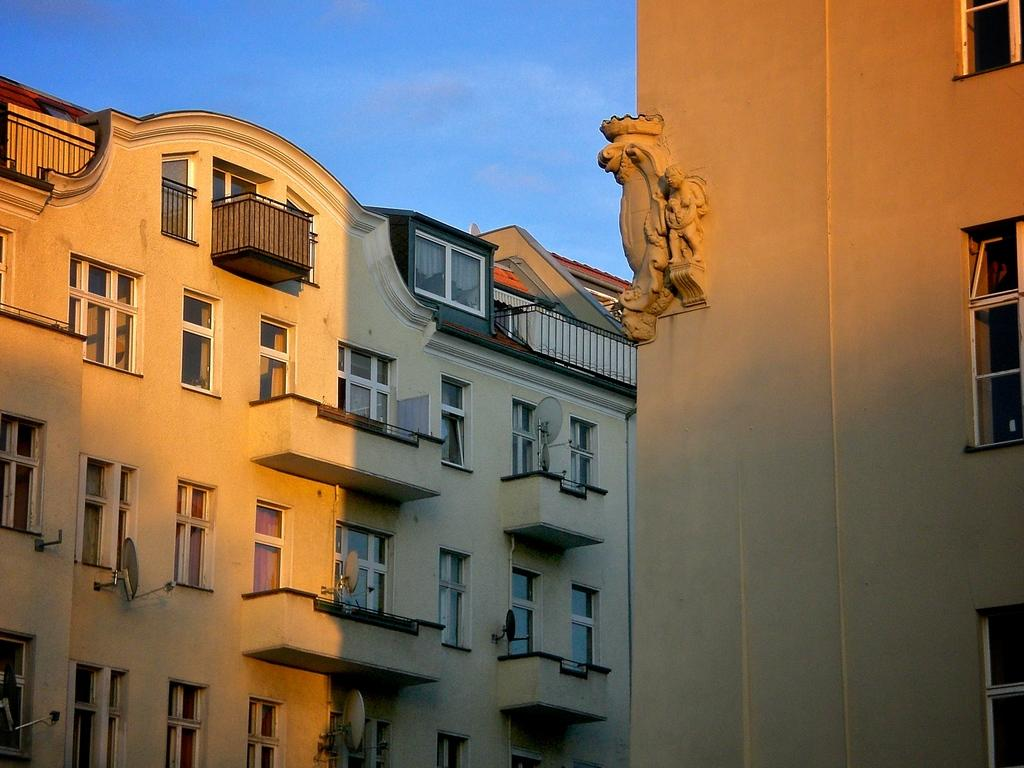What type of structures can be seen in the image? There are buildings in the image. What feature can be observed on the buildings? There are glass windows on the buildings. What communication device is present in the image? Dish TV antennas are present in the image. What can be seen in the background of the image? The sky is visible in the background of the image. What type of beef is being served at the son's birthday party in the image? There is no son or beef present in the image; it only features buildings, glass windows, Dish TV antennas, and the sky. 